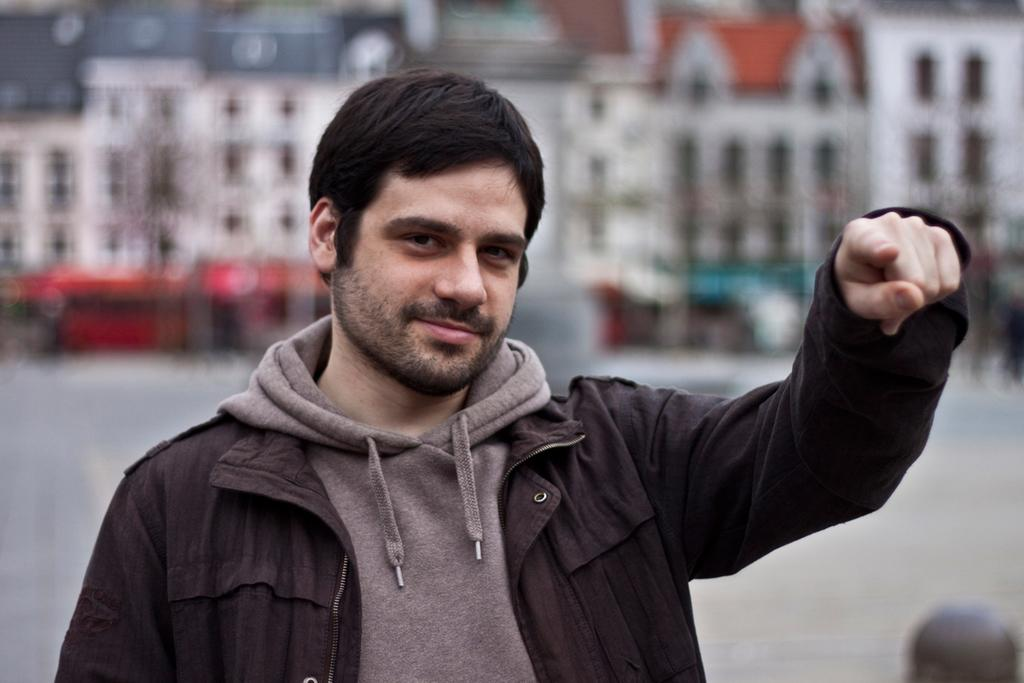What is the main subject of the image? There is a close-up picture of a man in the image. What can be observed about the man's attire? The man is wearing clothes. What is the man's facial expression in the image? The man is smiling. What can be seen in the background of the image? There are buildings visible in the background of the image. How is the background of the image depicted? The background is blurred. What type of yarn is the man holding in the image? There is no yarn present in the image; the man is not holding anything. What sound can be heard coming from the buildings in the background? There is no sound present in the image, as it is a still photograph. 